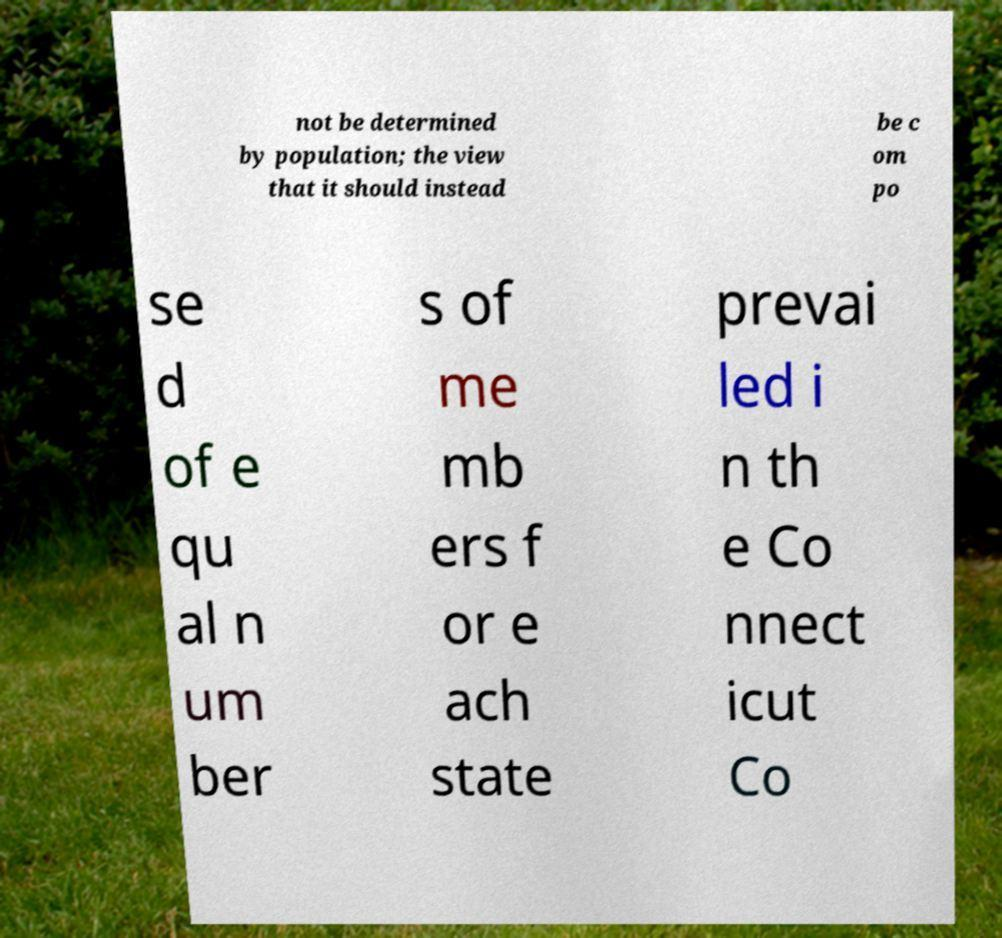Can you read and provide the text displayed in the image?This photo seems to have some interesting text. Can you extract and type it out for me? not be determined by population; the view that it should instead be c om po se d of e qu al n um ber s of me mb ers f or e ach state prevai led i n th e Co nnect icut Co 